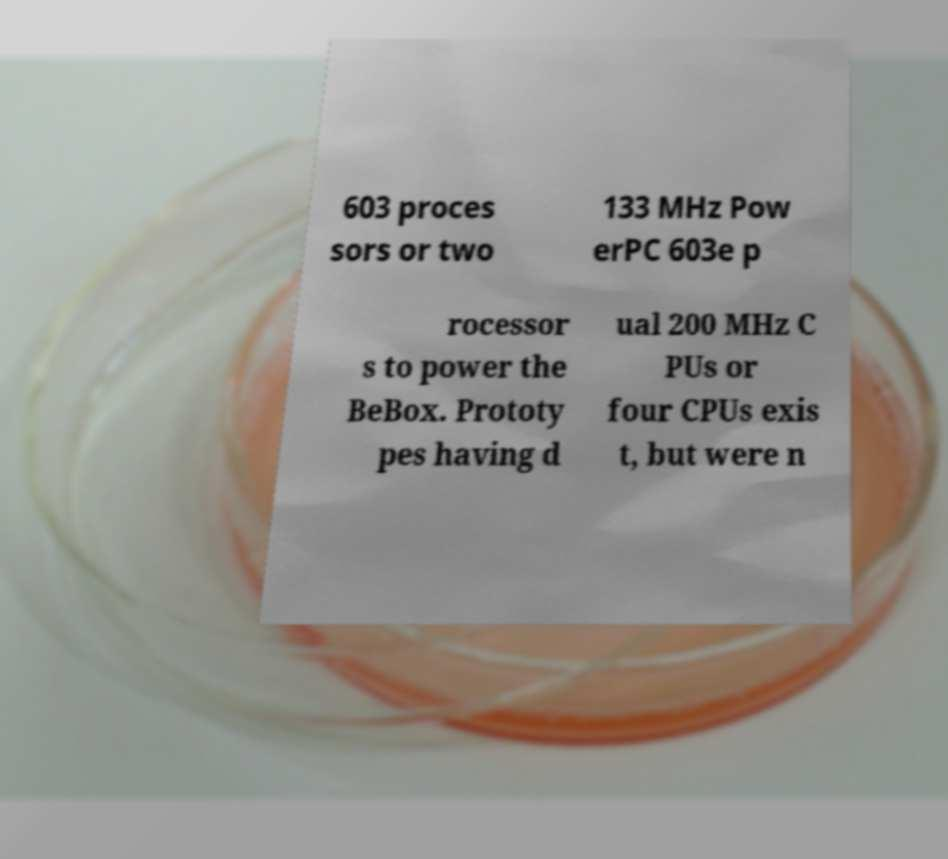Can you read and provide the text displayed in the image?This photo seems to have some interesting text. Can you extract and type it out for me? 603 proces sors or two 133 MHz Pow erPC 603e p rocessor s to power the BeBox. Prototy pes having d ual 200 MHz C PUs or four CPUs exis t, but were n 